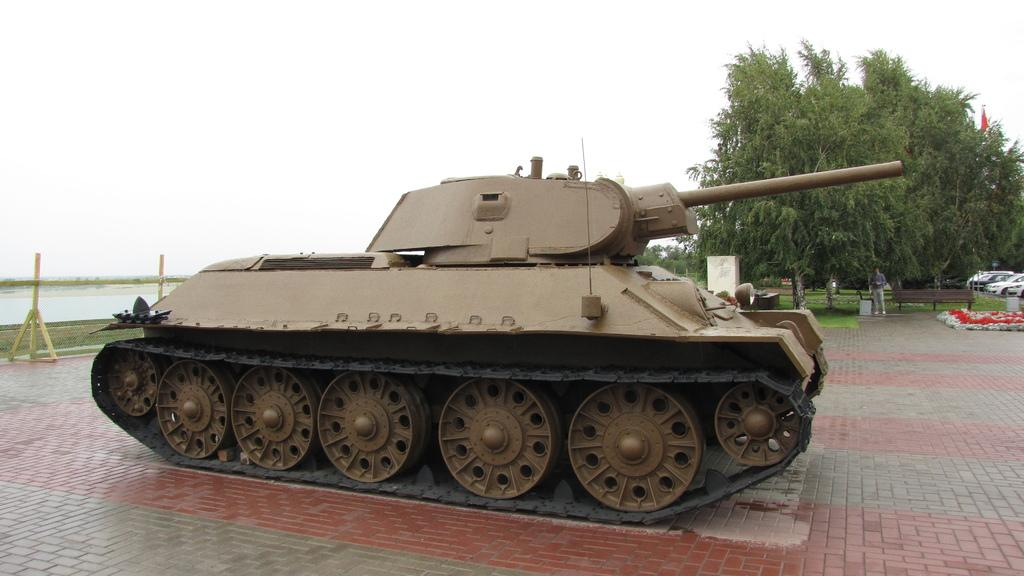What is the main subject of the image? The main subject of the image is a war tank. Can you describe the person in the image? There is a man standing at the back of the war tank. What type of natural environment is visible in the image? There are trees in the image. What type of seating is present in the image? There is a bench in the image. What symbol can be seen in the image? There is a flag in the image. What else is present in the image besides the war tank? There are vehicles and water visible in the image. What time does the clock show in the image? There is no clock present in the image. How tall are the giants in the image? There are no giants present in the image. 